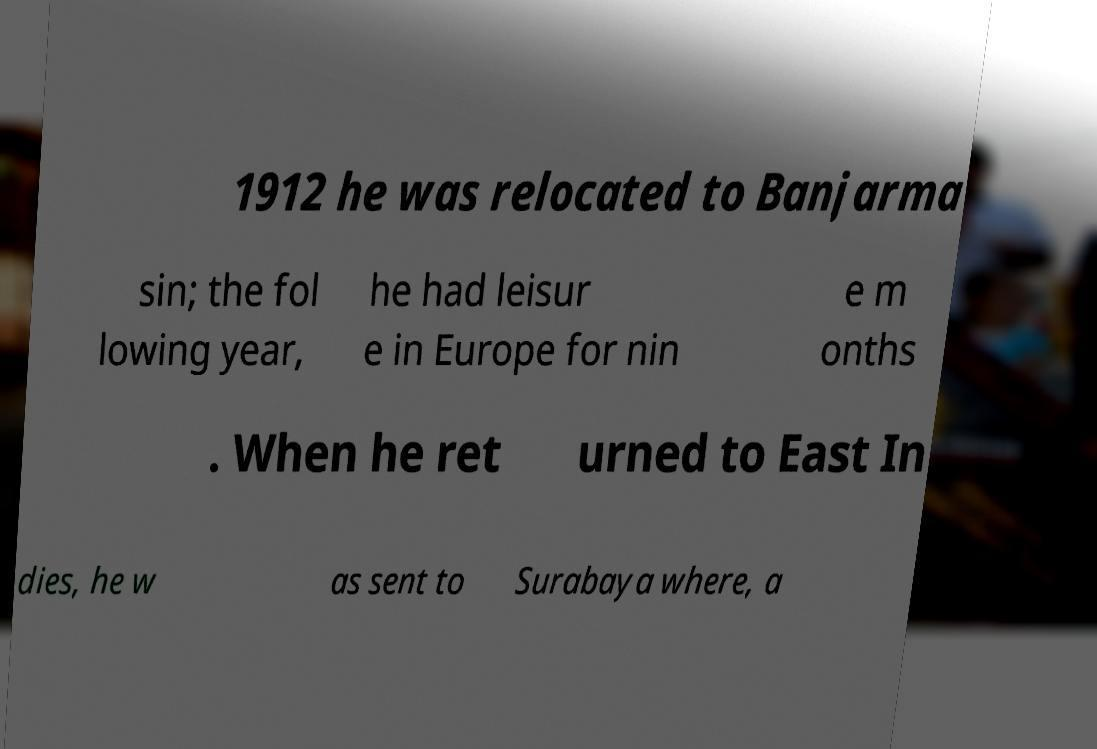Can you accurately transcribe the text from the provided image for me? 1912 he was relocated to Banjarma sin; the fol lowing year, he had leisur e in Europe for nin e m onths . When he ret urned to East In dies, he w as sent to Surabaya where, a 